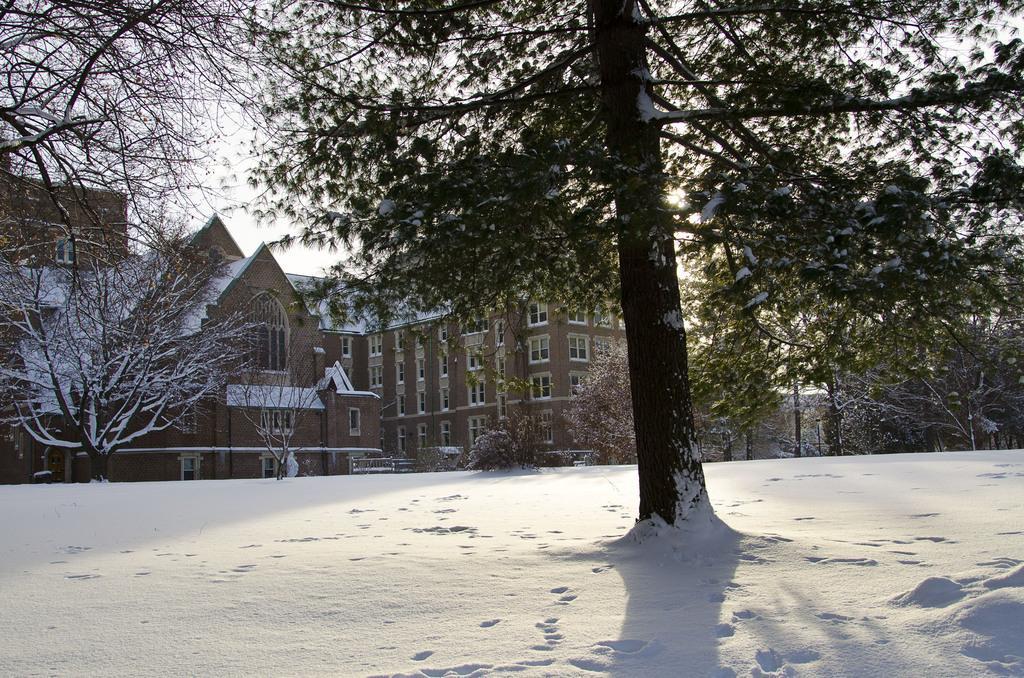In one or two sentences, can you explain what this image depicts? In this picture we can see that the trees ,the houses and the roads are covered with snow, And there is sunlight everywhere. 